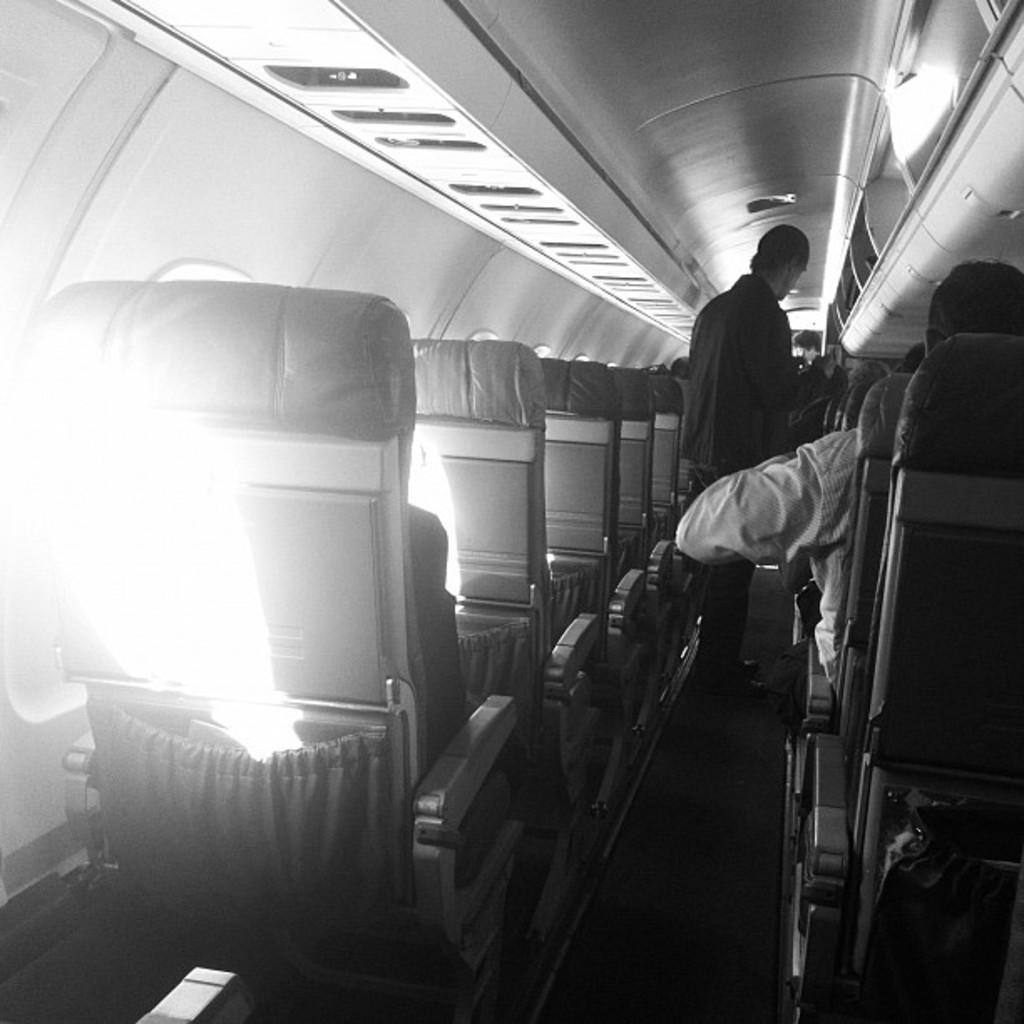Describe this image in one or two sentences. In this picture there is a inside view of the plane. In the front there are some seats and a man wearing a black color shirt is standing. Above on the roof there is a ac vent and luggage space. 